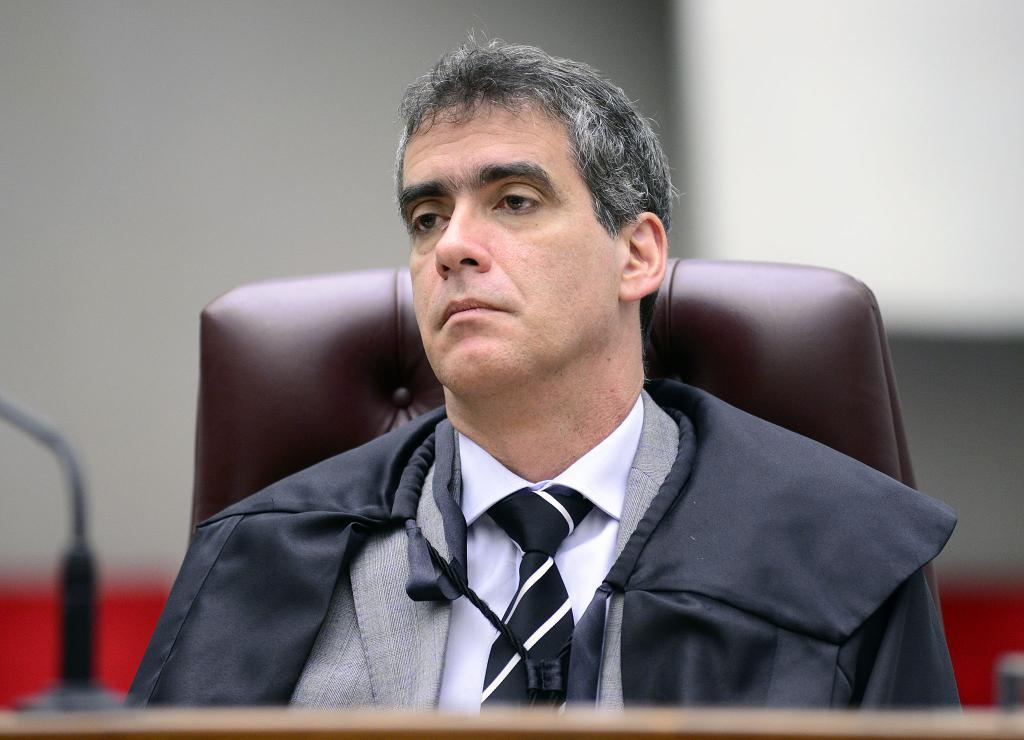What is the man in the image doing? The man is sitting on a chair in the image. What can be seen on the left side of the image? There is a stand on a platform on the left side of the image. How would you describe the background of the image? The background of the image is blurred. What structures are visible in the background of the image? There is a wall and a board visible in the background of the image. What type of rose is the man holding in the image? There is no rose present in the image; the man is sitting on a chair with no visible objects in his hands. 